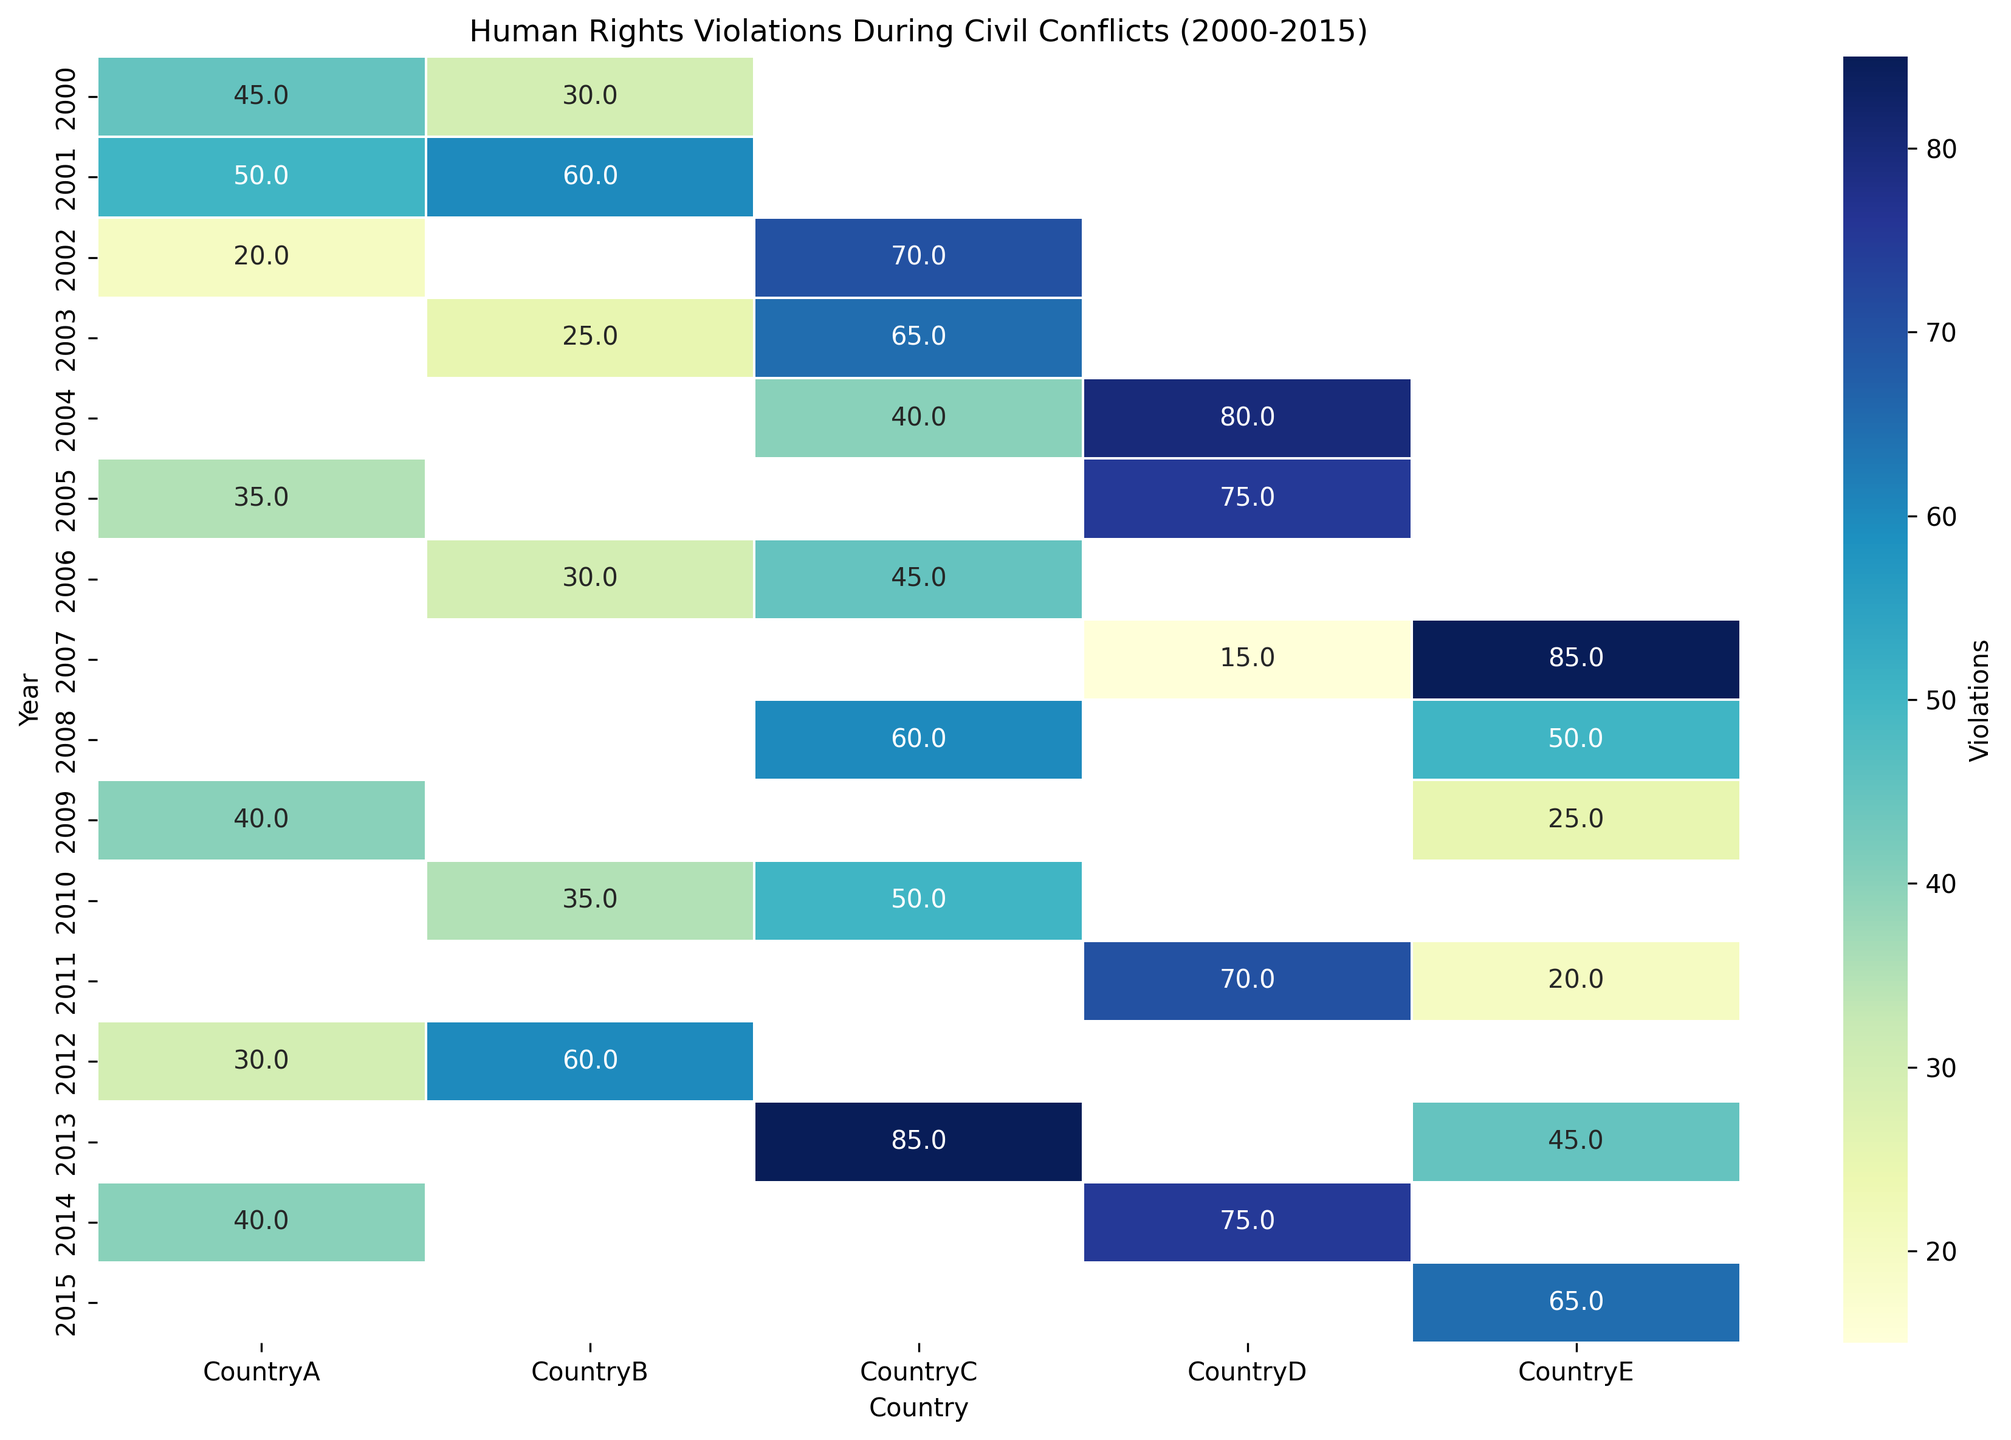Which country had the highest instances of human rights violations in 2000? In 2000, CountryA had 45 violations and CountryB had 30, with 45 being the higher number.
Answer: CountryA In which year did CountryD experience the highest number of human rights violations? Reviewing the values for CountryD, the highest number, 80, occurs in 2004.
Answer: 2004 Which country had the most consistent level of human rights violations from 2000 to 2015? To find the most consistent level, observe the intensity pattern for each country across the heatmap. CountryB has relatively even values, indicating consistency.
Answer: CountryB Did any country experience a decrease in human rights violations from one year to the next? If so, provide an example. Looking at the heatmap, from 2004 to 2005, CountryD's violations decreased from 80 to 75.
Answer: CountryD In which year did the overall human rights situation appear most diverse across the countries examined? Analyzing the heatmap, diversity between countries can be seen in 2004, where some countries have high violations and others have medium or low values.
Answer: 2004 Which country showed the highest increase in human rights violations between two consecutive years? Reviewing the values, CountryE showed an increase from 2007 (15) to 2008 (60), an increment of 45 violating instances.
Answer: CountryE What is the average number of human rights violations for CountryA over the entire period? Summing violations for CountryA (45, 50, 20, 35, 40, 30, 40) gives 260, divided by 7 years equals approximately 37.1.
Answer: 37.1 How do human rights violations in CountryE in 2015 compare to those in 2014? CountryE had 65 violations in 2015 and 45 in 2014. 65 is greater than 45.
Answer: Higher in 2015 Are there years where any country had exactly the same number of violations as another year for some other country? Checking the heatmap, CountryB had 60 violations in 2001 and another 60 in 2012.
Answer: Yes Which country exhibited the highest peak of violations recorded in a single year throughout the entire chart? Reviewing the heatmap, the highest peak is 85 violations recorded by CountryC in 2013.
Answer: CountryC 